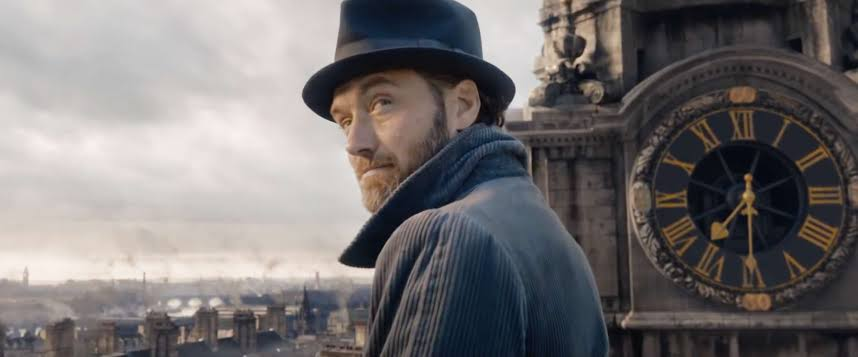Describe the symbolism of the clock in the background. The large clock in the background symbolizes the passage of time and could be hinting at a crucial moment or deadline that is pertinent to the character's storyline. It adds a visual emphasis on time, possibly alluding to themes of fate, destiny, or critical turning points in the narrative. 